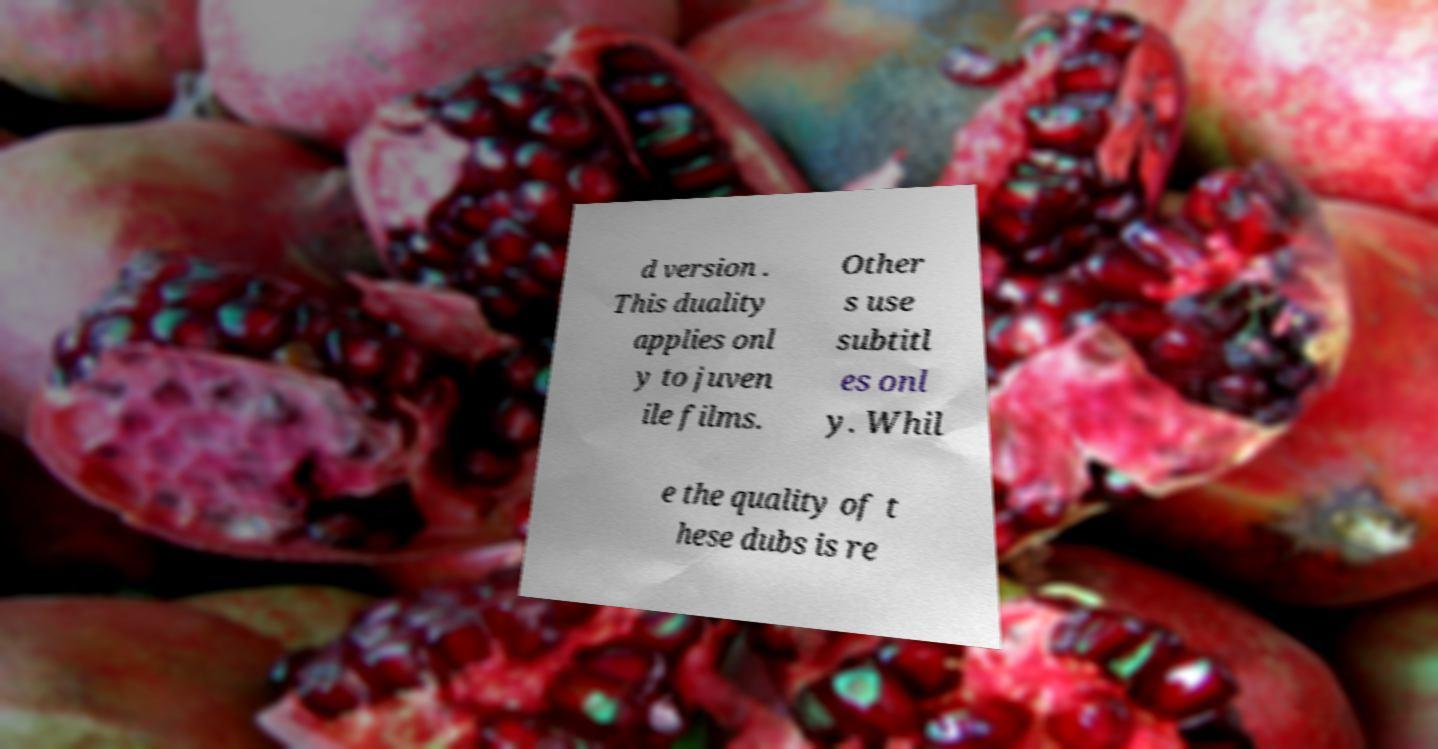Please read and relay the text visible in this image. What does it say? d version . This duality applies onl y to juven ile films. Other s use subtitl es onl y. Whil e the quality of t hese dubs is re 